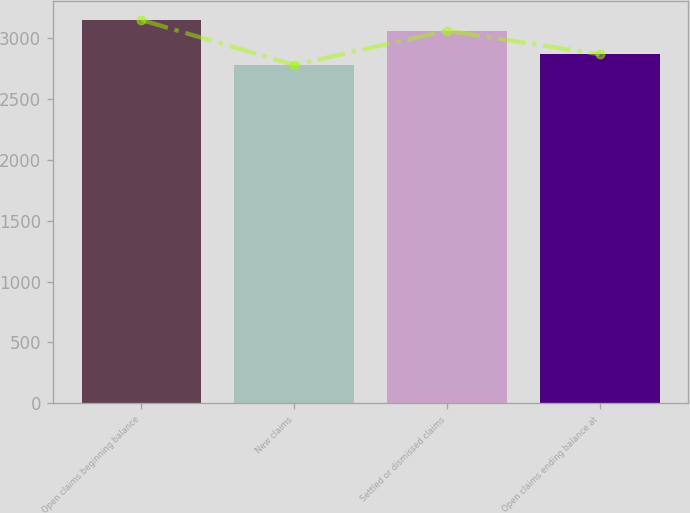<chart> <loc_0><loc_0><loc_500><loc_500><bar_chart><fcel>Open claims beginning balance<fcel>New claims<fcel>Settled or dismissed claims<fcel>Open claims ending balance at<nl><fcel>3151<fcel>2781<fcel>3063<fcel>2869<nl></chart> 